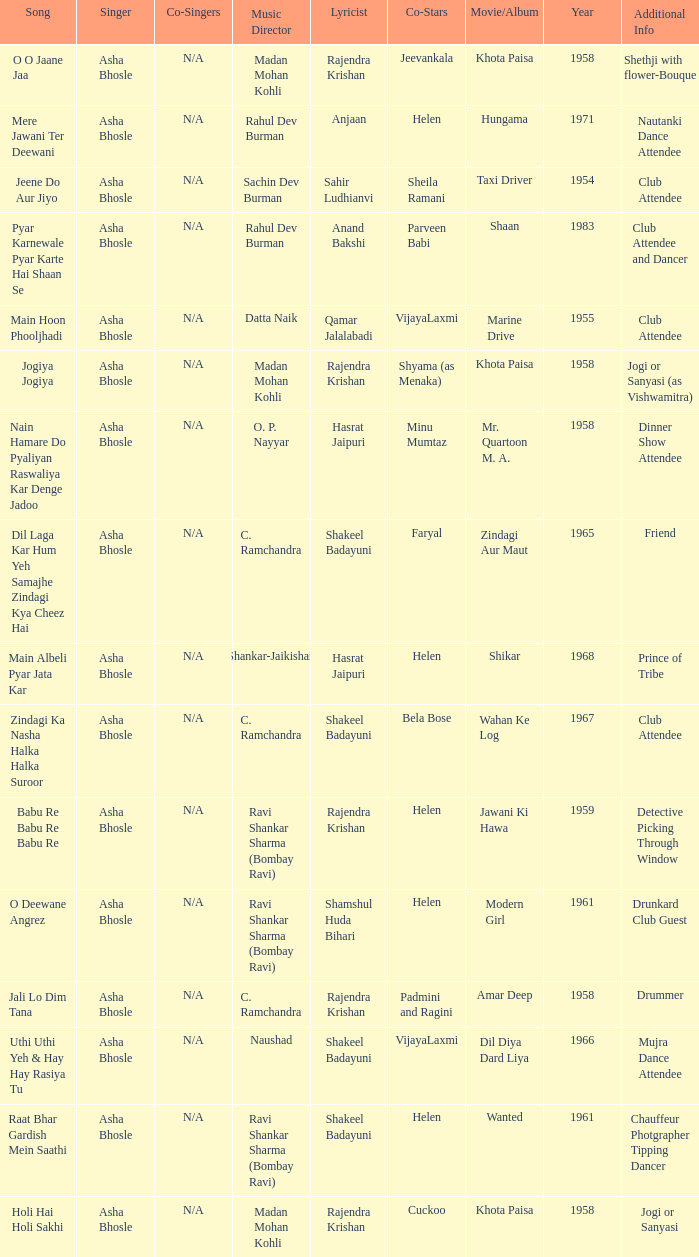Who wrote the lyrics when Jeevankala co-starred? Rajendra Krishan. 